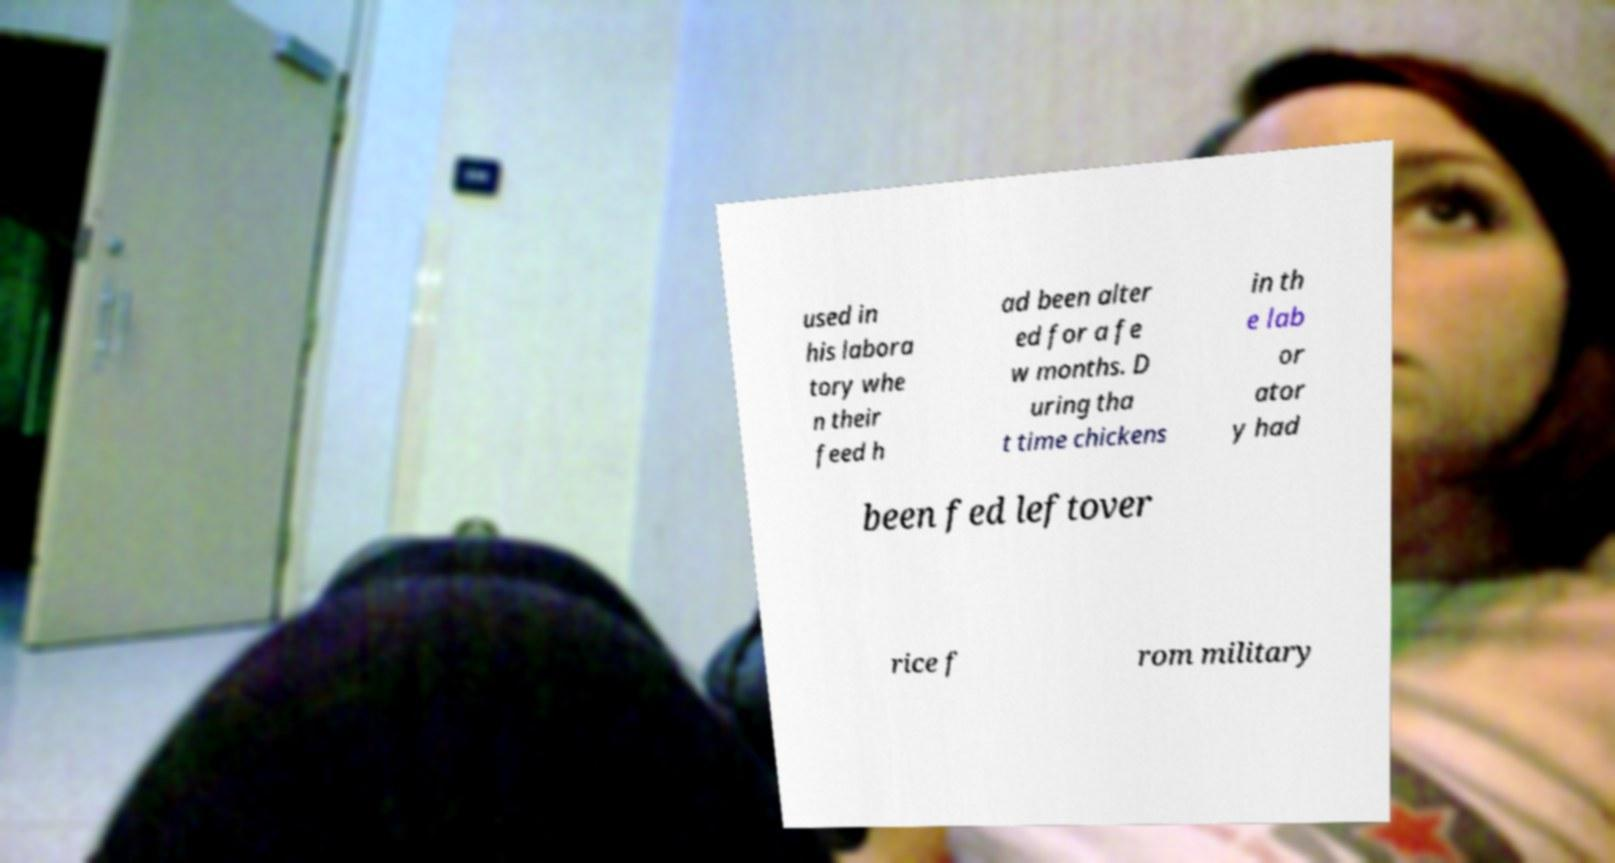Please read and relay the text visible in this image. What does it say? used in his labora tory whe n their feed h ad been alter ed for a fe w months. D uring tha t time chickens in th e lab or ator y had been fed leftover rice f rom military 